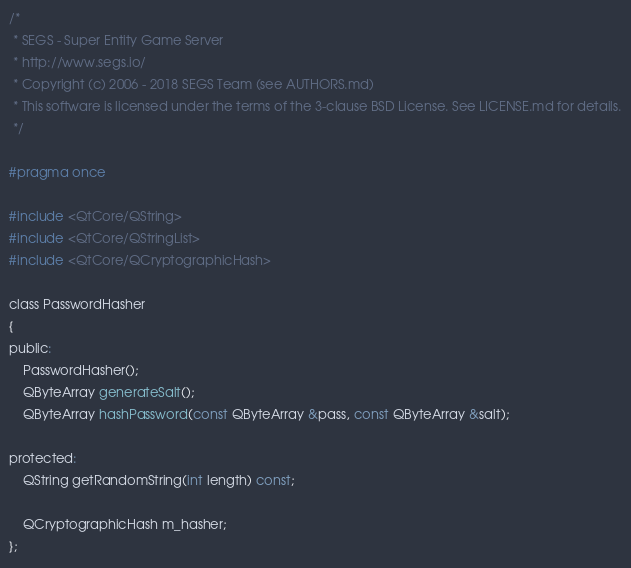<code> <loc_0><loc_0><loc_500><loc_500><_C_>/*
 * SEGS - Super Entity Game Server
 * http://www.segs.io/
 * Copyright (c) 2006 - 2018 SEGS Team (see AUTHORS.md)
 * This software is licensed under the terms of the 3-clause BSD License. See LICENSE.md for details.
 */

#pragma once

#include <QtCore/QString>
#include <QtCore/QStringList>
#include <QtCore/QCryptographicHash>

class PasswordHasher
{
public:
    PasswordHasher();
    QByteArray generateSalt();
    QByteArray hashPassword(const QByteArray &pass, const QByteArray &salt);

protected:
    QString getRandomString(int length) const;

    QCryptographicHash m_hasher;
};
</code> 